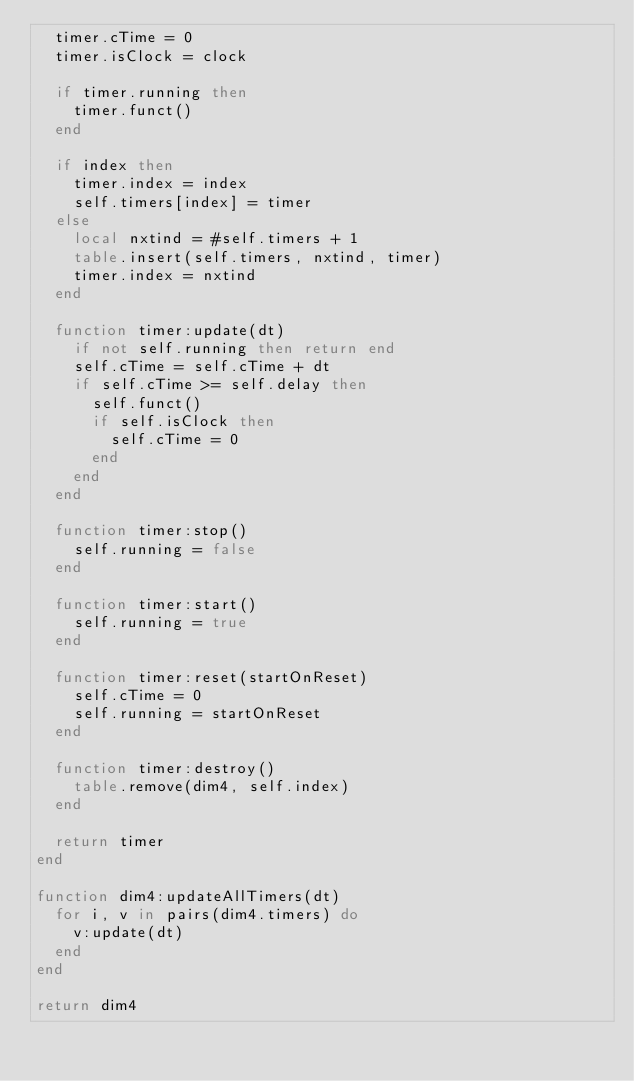Convert code to text. <code><loc_0><loc_0><loc_500><loc_500><_Lua_>	timer.cTime = 0
	timer.isClock = clock
	
	if timer.running then
		timer.funct()
	end

	if index then
		timer.index = index
		self.timers[index] = timer
	else
		local nxtind = #self.timers + 1
		table.insert(self.timers, nxtind, timer)
		timer.index = nxtind
	end

	function timer:update(dt)
		if not self.running then return end
		self.cTime = self.cTime + dt
		if self.cTime >= self.delay then
			self.funct()
			if self.isClock then
				self.cTime = 0
			end
		end
	end
		
	function timer:stop()
		self.running = false		
	end

	function timer:start()
		self.running = true
	end

	function timer:reset(startOnReset)
		self.cTime = 0
		self.running = startOnReset 
	end

	function timer:destroy()
		table.remove(dim4, self.index)
	end  

	return timer
end

function dim4:updateAllTimers(dt)
	for i, v in pairs(dim4.timers) do
		v:update(dt)
	end
end

return dim4</code> 